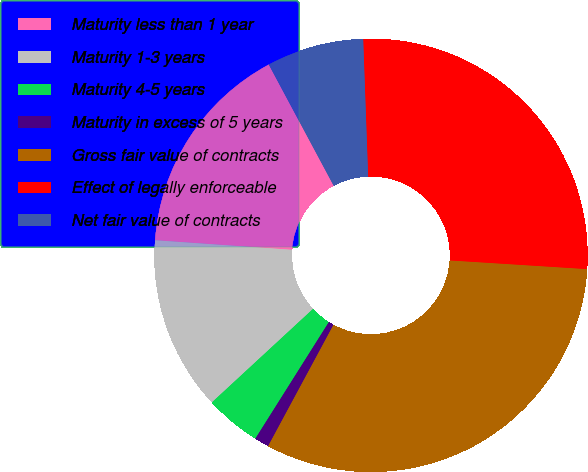Convert chart to OTSL. <chart><loc_0><loc_0><loc_500><loc_500><pie_chart><fcel>Maturity less than 1 year<fcel>Maturity 1-3 years<fcel>Maturity 4-5 years<fcel>Maturity in excess of 5 years<fcel>Gross fair value of contracts<fcel>Effect of legally enforceable<fcel>Net fair value of contracts<nl><fcel>16.06%<fcel>12.99%<fcel>4.17%<fcel>1.09%<fcel>31.86%<fcel>26.58%<fcel>7.25%<nl></chart> 